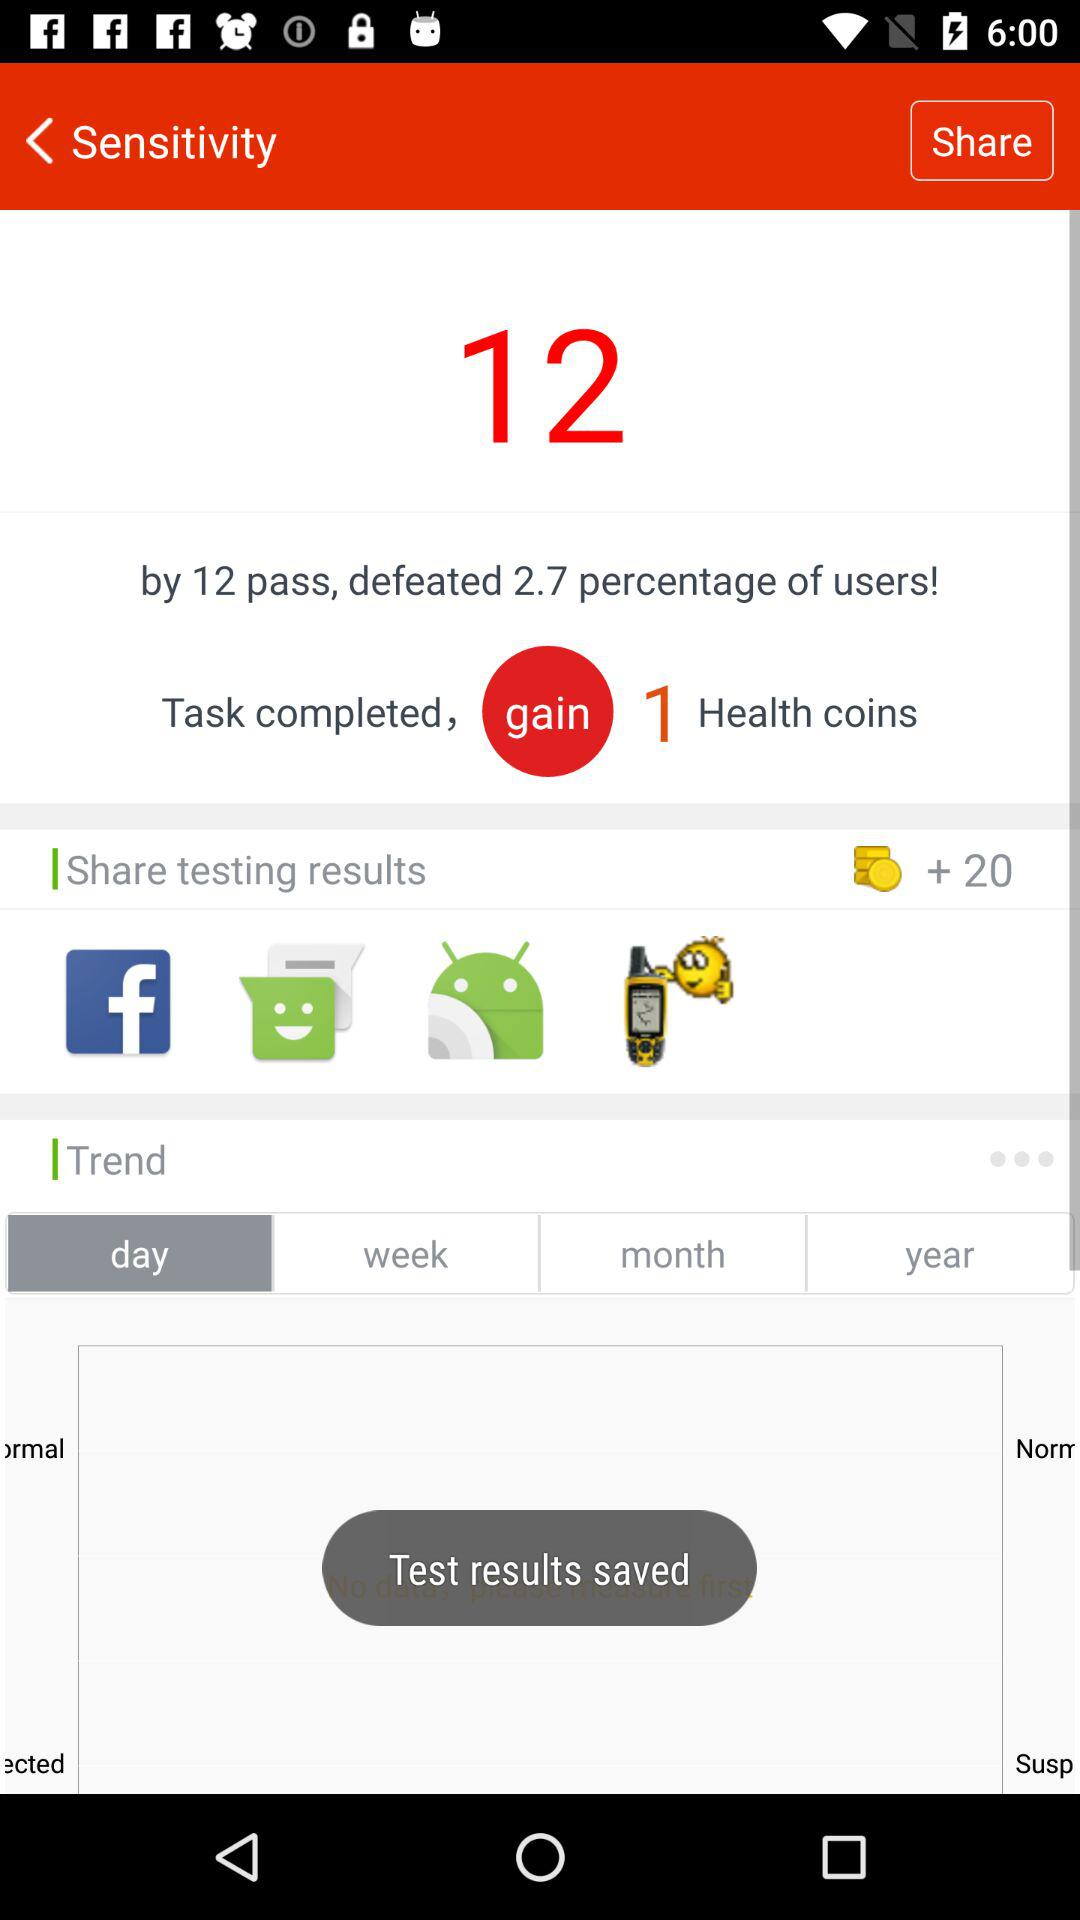How many more tasks did you complete than the average user? Based on the information displayed, you've completed 12 tasks more than the average user, which is a significant achievement considering it places you ahead of 2.7% of users. Well done! 